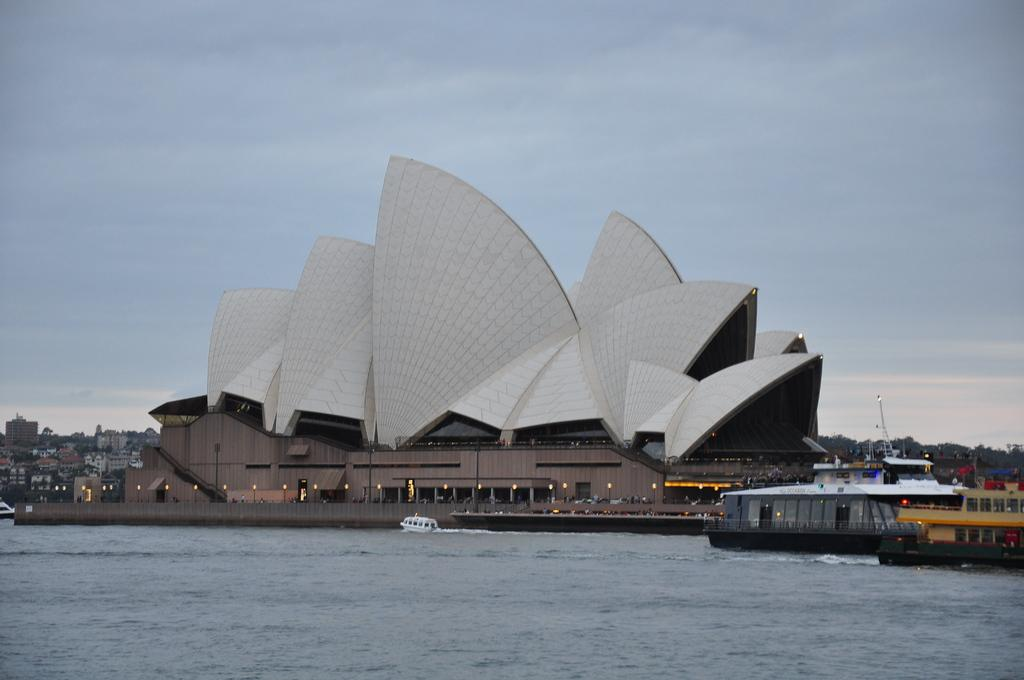What types of vehicles are in the image? There are ships and boats in the image. Where are the ships and boats located in relation to the water? The ships and boats are above the water. What other structures can be seen in the image? There are buildings in the image. What can be seen illuminating the scene in the image? Lights are visible in the image. What is visible in the background of the image? The sky is visible in the background of the image. What type of trouble is the box causing in the image? There is no box present in the image, so it cannot cause any trouble. 